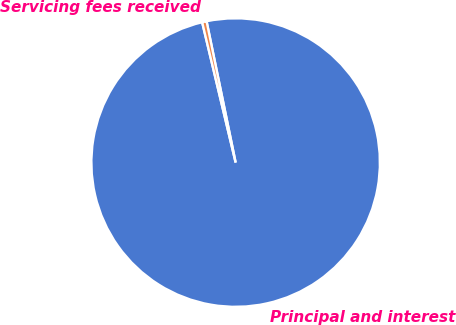Convert chart. <chart><loc_0><loc_0><loc_500><loc_500><pie_chart><fcel>Principal and interest<fcel>Servicing fees received<nl><fcel>99.5%<fcel>0.5%<nl></chart> 